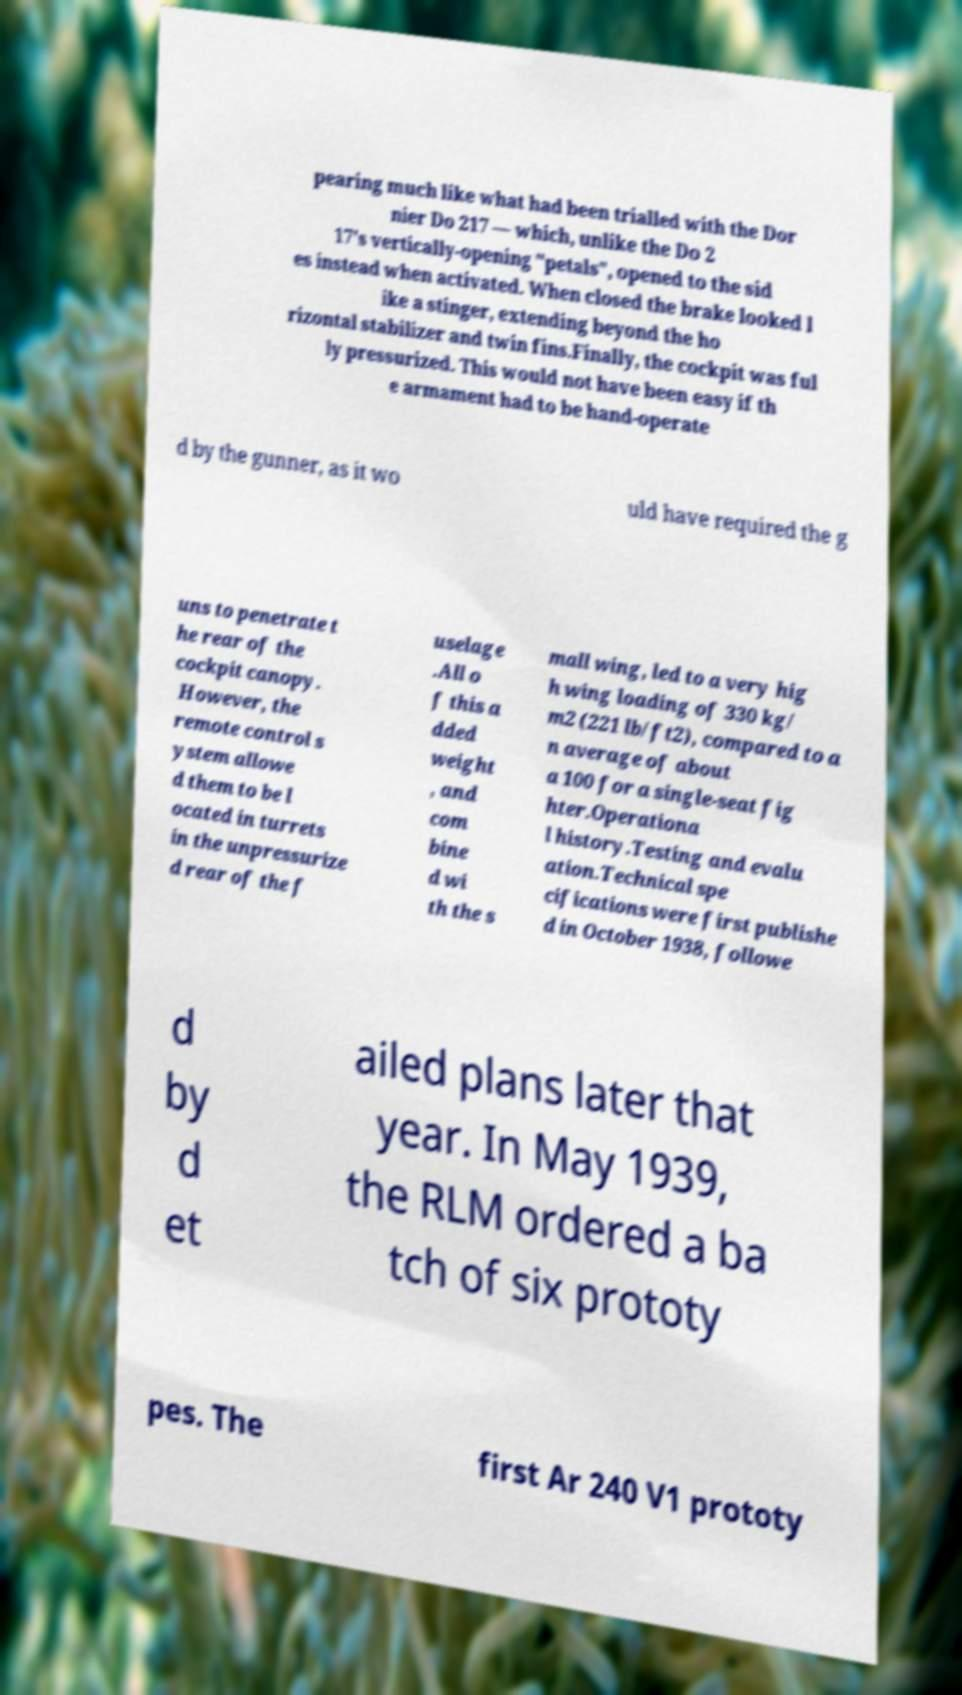For documentation purposes, I need the text within this image transcribed. Could you provide that? pearing much like what had been trialled with the Dor nier Do 217 — which, unlike the Do 2 17's vertically-opening "petals", opened to the sid es instead when activated. When closed the brake looked l ike a stinger, extending beyond the ho rizontal stabilizer and twin fins.Finally, the cockpit was ful ly pressurized. This would not have been easy if th e armament had to be hand-operate d by the gunner, as it wo uld have required the g uns to penetrate t he rear of the cockpit canopy. However, the remote control s ystem allowe d them to be l ocated in turrets in the unpressurize d rear of the f uselage .All o f this a dded weight , and com bine d wi th the s mall wing, led to a very hig h wing loading of 330 kg/ m2 (221 lb/ft2), compared to a n average of about a 100 for a single-seat fig hter.Operationa l history.Testing and evalu ation.Technical spe cifications were first publishe d in October 1938, followe d by d et ailed plans later that year. In May 1939, the RLM ordered a ba tch of six prototy pes. The first Ar 240 V1 prototy 